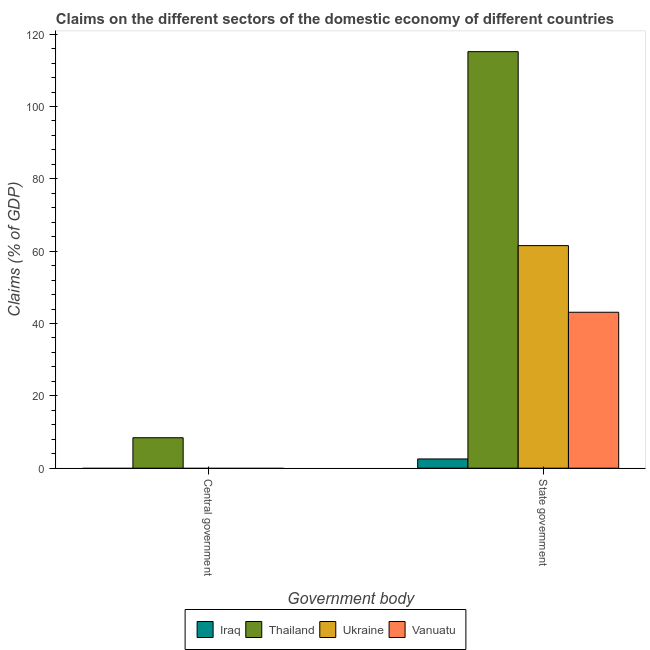Are the number of bars per tick equal to the number of legend labels?
Provide a succinct answer. No. Are the number of bars on each tick of the X-axis equal?
Keep it short and to the point. No. What is the label of the 2nd group of bars from the left?
Provide a short and direct response. State government. Across all countries, what is the maximum claims on central government?
Offer a terse response. 8.42. In which country was the claims on state government maximum?
Provide a succinct answer. Thailand. What is the total claims on state government in the graph?
Your response must be concise. 222.38. What is the difference between the claims on state government in Ukraine and that in Iraq?
Ensure brevity in your answer.  58.99. What is the difference between the claims on state government in Vanuatu and the claims on central government in Iraq?
Your answer should be very brief. 43.12. What is the average claims on state government per country?
Your answer should be very brief. 55.6. What is the difference between the claims on central government and claims on state government in Thailand?
Provide a succinct answer. -106.75. In how many countries, is the claims on central government greater than 16 %?
Your response must be concise. 0. What is the ratio of the claims on state government in Vanuatu to that in Iraq?
Provide a succinct answer. 16.88. In how many countries, is the claims on central government greater than the average claims on central government taken over all countries?
Provide a short and direct response. 1. Are all the bars in the graph horizontal?
Ensure brevity in your answer.  No. How many countries are there in the graph?
Your answer should be very brief. 4. What is the difference between two consecutive major ticks on the Y-axis?
Ensure brevity in your answer.  20. Are the values on the major ticks of Y-axis written in scientific E-notation?
Ensure brevity in your answer.  No. Does the graph contain any zero values?
Ensure brevity in your answer.  Yes. Does the graph contain grids?
Ensure brevity in your answer.  No. How are the legend labels stacked?
Offer a very short reply. Horizontal. What is the title of the graph?
Keep it short and to the point. Claims on the different sectors of the domestic economy of different countries. Does "Chad" appear as one of the legend labels in the graph?
Give a very brief answer. No. What is the label or title of the X-axis?
Provide a succinct answer. Government body. What is the label or title of the Y-axis?
Keep it short and to the point. Claims (% of GDP). What is the Claims (% of GDP) of Iraq in Central government?
Make the answer very short. 0. What is the Claims (% of GDP) in Thailand in Central government?
Your answer should be very brief. 8.42. What is the Claims (% of GDP) in Vanuatu in Central government?
Give a very brief answer. 0. What is the Claims (% of GDP) in Iraq in State government?
Make the answer very short. 2.55. What is the Claims (% of GDP) in Thailand in State government?
Give a very brief answer. 115.17. What is the Claims (% of GDP) in Ukraine in State government?
Offer a terse response. 61.54. What is the Claims (% of GDP) in Vanuatu in State government?
Make the answer very short. 43.12. Across all Government body, what is the maximum Claims (% of GDP) in Iraq?
Your answer should be compact. 2.55. Across all Government body, what is the maximum Claims (% of GDP) of Thailand?
Make the answer very short. 115.17. Across all Government body, what is the maximum Claims (% of GDP) in Ukraine?
Your answer should be compact. 61.54. Across all Government body, what is the maximum Claims (% of GDP) in Vanuatu?
Your answer should be very brief. 43.12. Across all Government body, what is the minimum Claims (% of GDP) of Iraq?
Offer a terse response. 0. Across all Government body, what is the minimum Claims (% of GDP) of Thailand?
Your answer should be compact. 8.42. Across all Government body, what is the minimum Claims (% of GDP) in Vanuatu?
Keep it short and to the point. 0. What is the total Claims (% of GDP) in Iraq in the graph?
Keep it short and to the point. 2.55. What is the total Claims (% of GDP) of Thailand in the graph?
Offer a terse response. 123.59. What is the total Claims (% of GDP) in Ukraine in the graph?
Offer a very short reply. 61.54. What is the total Claims (% of GDP) in Vanuatu in the graph?
Provide a succinct answer. 43.12. What is the difference between the Claims (% of GDP) of Thailand in Central government and that in State government?
Keep it short and to the point. -106.75. What is the difference between the Claims (% of GDP) of Thailand in Central government and the Claims (% of GDP) of Ukraine in State government?
Keep it short and to the point. -53.12. What is the difference between the Claims (% of GDP) in Thailand in Central government and the Claims (% of GDP) in Vanuatu in State government?
Give a very brief answer. -34.7. What is the average Claims (% of GDP) of Iraq per Government body?
Give a very brief answer. 1.28. What is the average Claims (% of GDP) of Thailand per Government body?
Give a very brief answer. 61.8. What is the average Claims (% of GDP) in Ukraine per Government body?
Your answer should be compact. 30.77. What is the average Claims (% of GDP) in Vanuatu per Government body?
Keep it short and to the point. 21.56. What is the difference between the Claims (% of GDP) in Iraq and Claims (% of GDP) in Thailand in State government?
Keep it short and to the point. -112.62. What is the difference between the Claims (% of GDP) in Iraq and Claims (% of GDP) in Ukraine in State government?
Make the answer very short. -58.99. What is the difference between the Claims (% of GDP) in Iraq and Claims (% of GDP) in Vanuatu in State government?
Your answer should be compact. -40.56. What is the difference between the Claims (% of GDP) in Thailand and Claims (% of GDP) in Ukraine in State government?
Make the answer very short. 53.63. What is the difference between the Claims (% of GDP) in Thailand and Claims (% of GDP) in Vanuatu in State government?
Provide a short and direct response. 72.06. What is the difference between the Claims (% of GDP) in Ukraine and Claims (% of GDP) in Vanuatu in State government?
Your answer should be very brief. 18.43. What is the ratio of the Claims (% of GDP) of Thailand in Central government to that in State government?
Ensure brevity in your answer.  0.07. What is the difference between the highest and the second highest Claims (% of GDP) of Thailand?
Give a very brief answer. 106.75. What is the difference between the highest and the lowest Claims (% of GDP) of Iraq?
Offer a very short reply. 2.55. What is the difference between the highest and the lowest Claims (% of GDP) of Thailand?
Ensure brevity in your answer.  106.75. What is the difference between the highest and the lowest Claims (% of GDP) in Ukraine?
Provide a succinct answer. 61.54. What is the difference between the highest and the lowest Claims (% of GDP) in Vanuatu?
Offer a terse response. 43.12. 